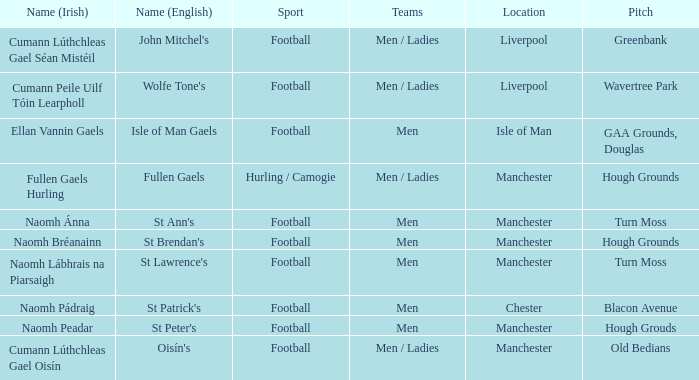What is the english designation for the site found in chester? St Patrick's. 